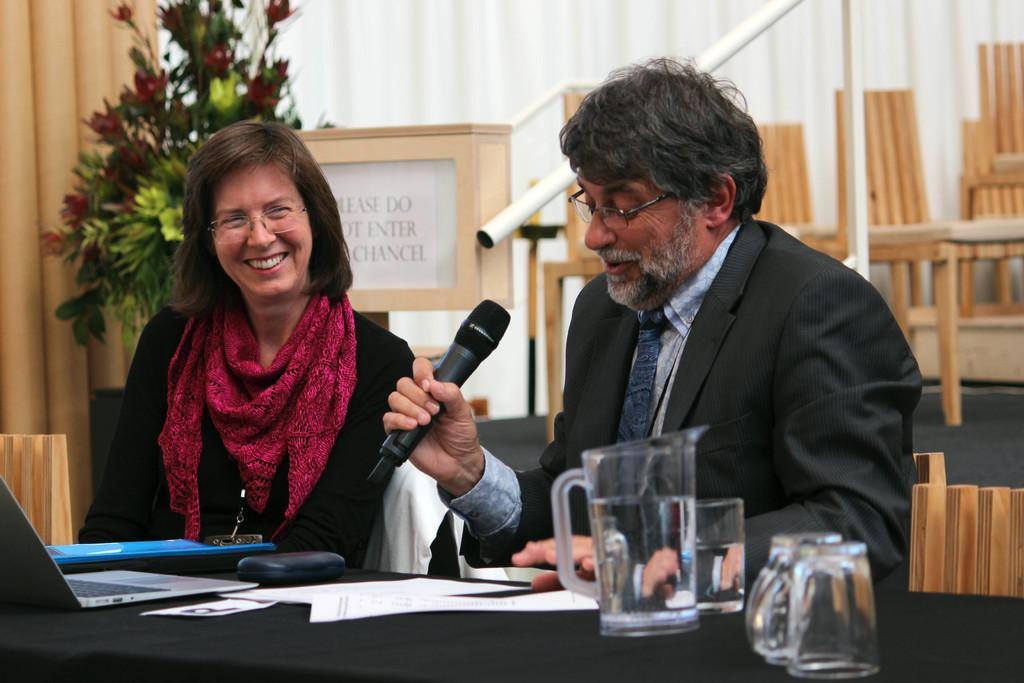In one or two sentences, can you explain what this image depicts? In the image we can see there are people who are sitting on chair and a man is holding mic in his hand and on table there are jug, glasses, papers, laptop and specs box. The woman is wearing red colour scarf. At the back there are chairs and a flower bouquet. 